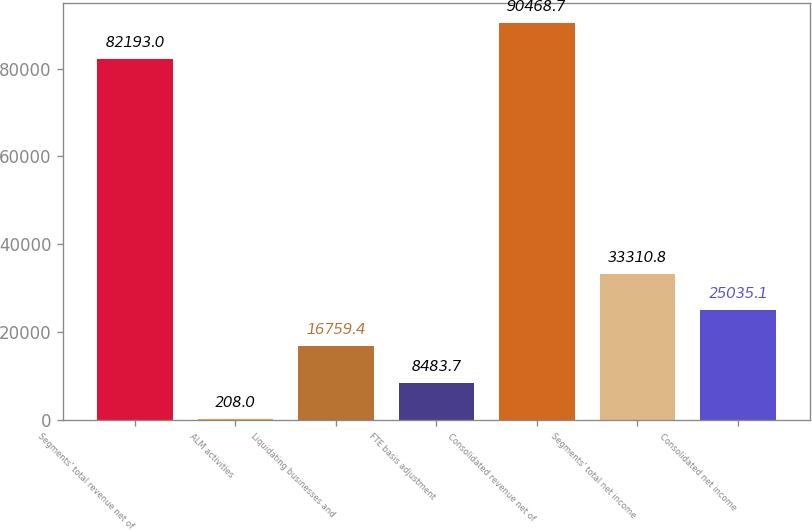<chart> <loc_0><loc_0><loc_500><loc_500><bar_chart><fcel>Segments' total revenue net of<fcel>ALM activities<fcel>Liquidating businesses and<fcel>FTE basis adjustment<fcel>Consolidated revenue net of<fcel>Segments' total net income<fcel>Consolidated net income<nl><fcel>82193<fcel>208<fcel>16759.4<fcel>8483.7<fcel>90468.7<fcel>33310.8<fcel>25035.1<nl></chart> 